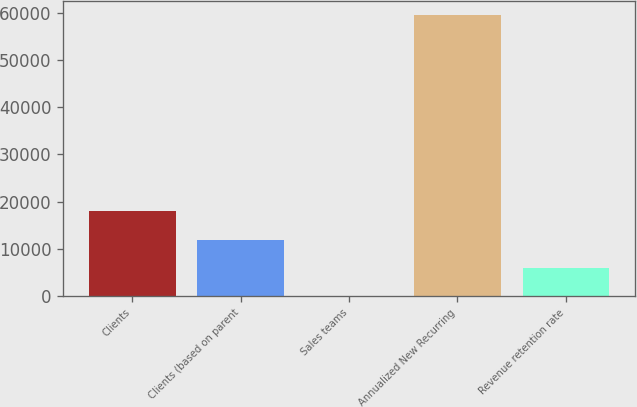Convert chart to OTSL. <chart><loc_0><loc_0><loc_500><loc_500><bar_chart><fcel>Clients<fcel>Clients (based on parent<fcel>Sales teams<fcel>Annualized New Recurring<fcel>Revenue retention rate<nl><fcel>17910.4<fcel>11950.6<fcel>31<fcel>59629<fcel>5990.8<nl></chart> 